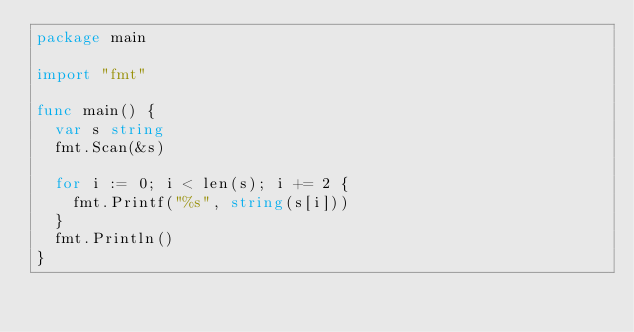<code> <loc_0><loc_0><loc_500><loc_500><_Go_>package main

import "fmt"

func main() {
	var s string
	fmt.Scan(&s)

	for i := 0; i < len(s); i += 2 {
		fmt.Printf("%s", string(s[i]))
	}
	fmt.Println()
}
</code> 